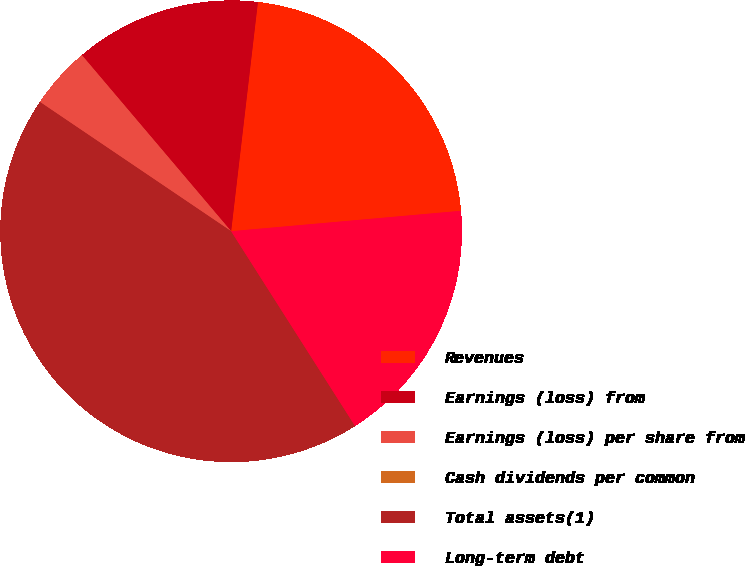<chart> <loc_0><loc_0><loc_500><loc_500><pie_chart><fcel>Revenues<fcel>Earnings (loss) from<fcel>Earnings (loss) per share from<fcel>Cash dividends per common<fcel>Total assets(1)<fcel>Long-term debt<nl><fcel>21.74%<fcel>13.04%<fcel>4.35%<fcel>0.0%<fcel>43.48%<fcel>17.39%<nl></chart> 